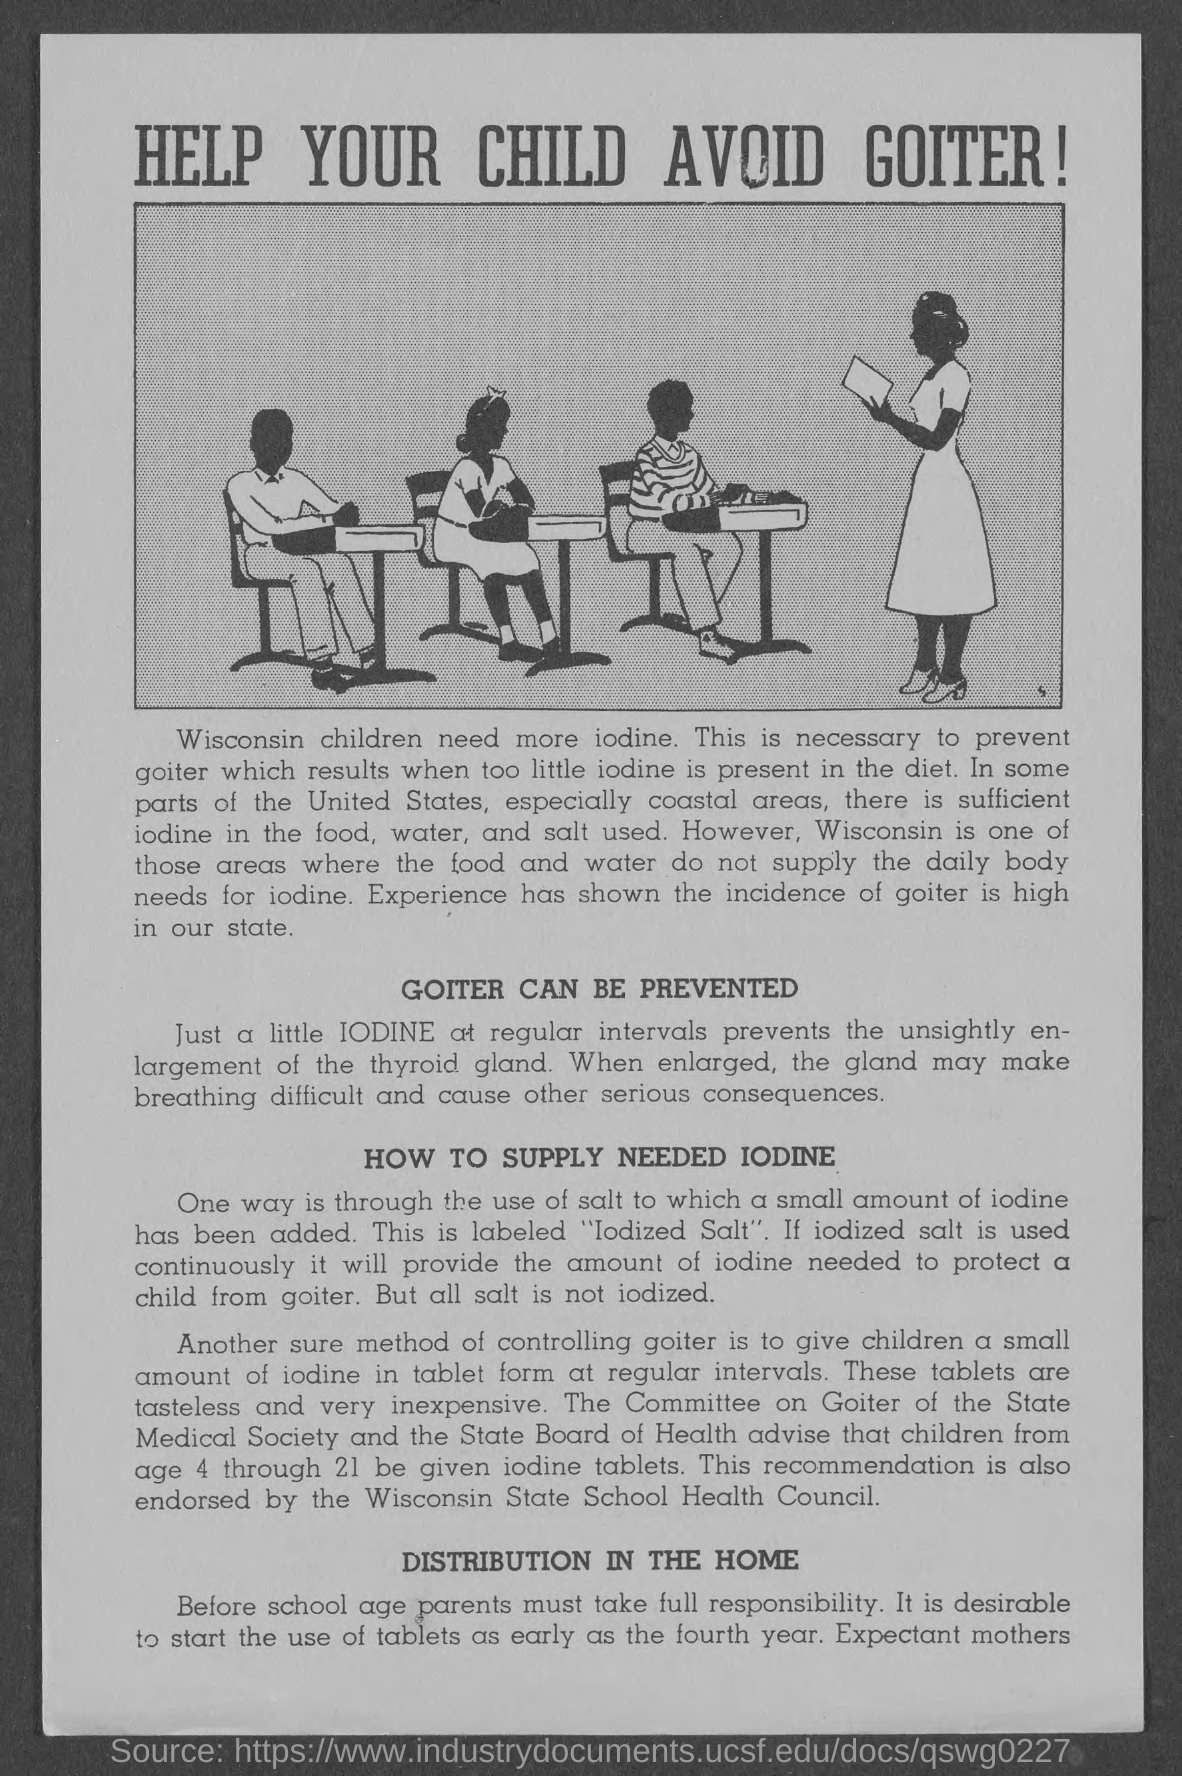What is the heading at top of the page ?
Offer a terse response. Help your child avoid goiter. What is the heading of second paragraph ?
Make the answer very short. Goiter can be prevented. What is the heading of third paragraph?
Ensure brevity in your answer.  How to supply needed iodine. What is the heading of the fourth paragraph?
Give a very brief answer. Distribution in the home. 